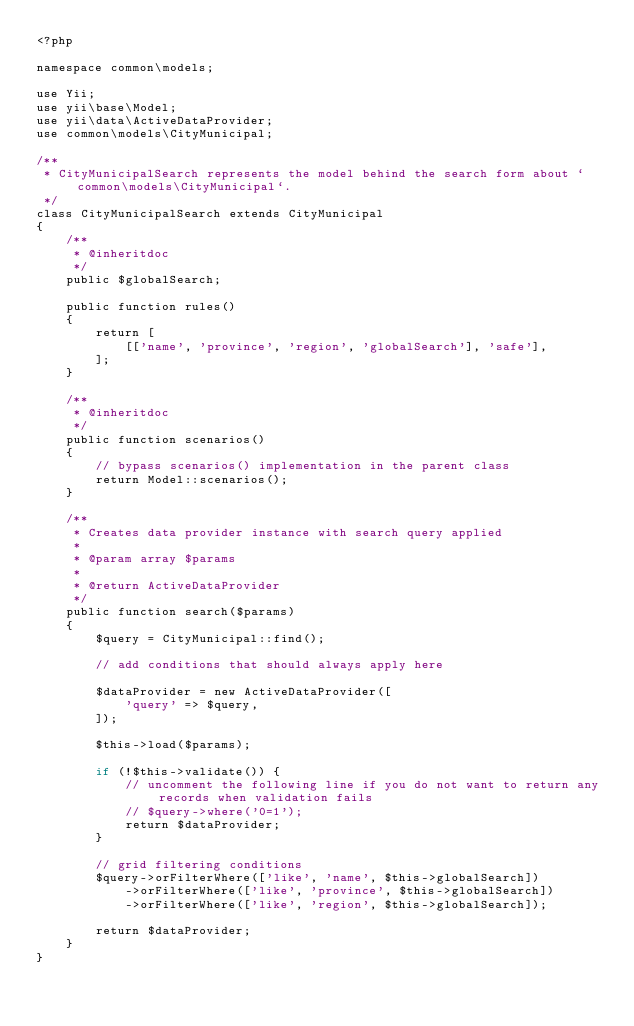<code> <loc_0><loc_0><loc_500><loc_500><_PHP_><?php

namespace common\models;

use Yii;
use yii\base\Model;
use yii\data\ActiveDataProvider;
use common\models\CityMunicipal;

/**
 * CityMunicipalSearch represents the model behind the search form about `common\models\CityMunicipal`.
 */
class CityMunicipalSearch extends CityMunicipal
{
    /**
     * @inheritdoc
     */
    public $globalSearch;

    public function rules()
    {
        return [
            [['name', 'province', 'region', 'globalSearch'], 'safe'],
        ];
    }

    /**
     * @inheritdoc
     */
    public function scenarios()
    {
        // bypass scenarios() implementation in the parent class
        return Model::scenarios();
    }

    /**
     * Creates data provider instance with search query applied
     *
     * @param array $params
     *
     * @return ActiveDataProvider
     */
    public function search($params)
    {
        $query = CityMunicipal::find();

        // add conditions that should always apply here

        $dataProvider = new ActiveDataProvider([
            'query' => $query,
        ]);

        $this->load($params);

        if (!$this->validate()) {
            // uncomment the following line if you do not want to return any records when validation fails
            // $query->where('0=1');
            return $dataProvider;
        }

        // grid filtering conditions
        $query->orFilterWhere(['like', 'name', $this->globalSearch])
            ->orFilterWhere(['like', 'province', $this->globalSearch])
            ->orFilterWhere(['like', 'region', $this->globalSearch]);

        return $dataProvider;
    }
}
</code> 